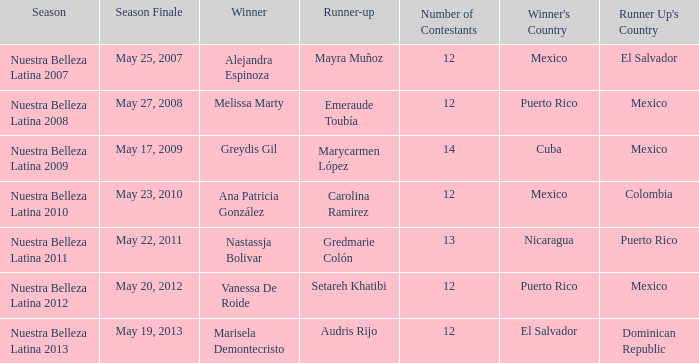What season had mexico as the runner up with melissa marty winning? Nuestra Belleza Latina 2008. 